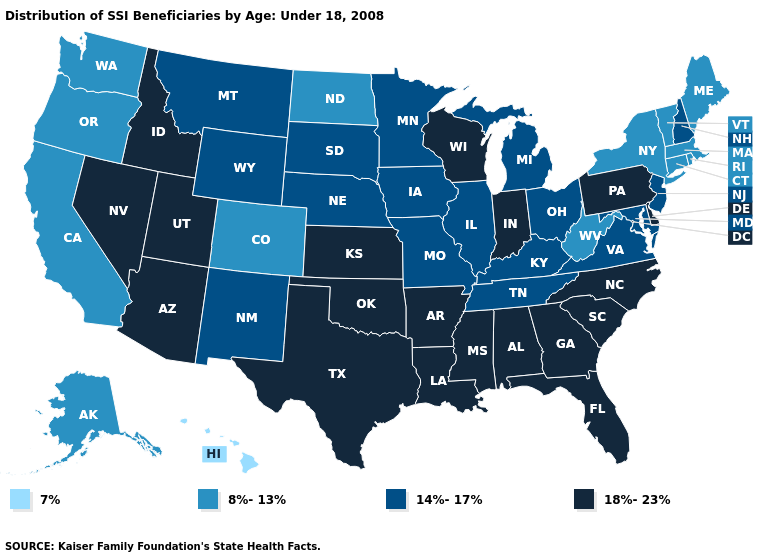Among the states that border Arizona , does Utah have the lowest value?
Give a very brief answer. No. Among the states that border Arkansas , does Louisiana have the highest value?
Answer briefly. Yes. Does the first symbol in the legend represent the smallest category?
Give a very brief answer. Yes. What is the highest value in the USA?
Quick response, please. 18%-23%. What is the highest value in the Northeast ?
Be succinct. 18%-23%. Name the states that have a value in the range 18%-23%?
Be succinct. Alabama, Arizona, Arkansas, Delaware, Florida, Georgia, Idaho, Indiana, Kansas, Louisiana, Mississippi, Nevada, North Carolina, Oklahoma, Pennsylvania, South Carolina, Texas, Utah, Wisconsin. What is the value of North Carolina?
Concise answer only. 18%-23%. What is the value of Alaska?
Be succinct. 8%-13%. Among the states that border Arizona , does California have the lowest value?
Quick response, please. Yes. What is the highest value in the South ?
Short answer required. 18%-23%. Which states have the lowest value in the South?
Write a very short answer. West Virginia. Does Ohio have a higher value than Oregon?
Write a very short answer. Yes. Name the states that have a value in the range 18%-23%?
Short answer required. Alabama, Arizona, Arkansas, Delaware, Florida, Georgia, Idaho, Indiana, Kansas, Louisiana, Mississippi, Nevada, North Carolina, Oklahoma, Pennsylvania, South Carolina, Texas, Utah, Wisconsin. What is the highest value in states that border New Mexico?
Keep it brief. 18%-23%. Name the states that have a value in the range 7%?
Be succinct. Hawaii. 